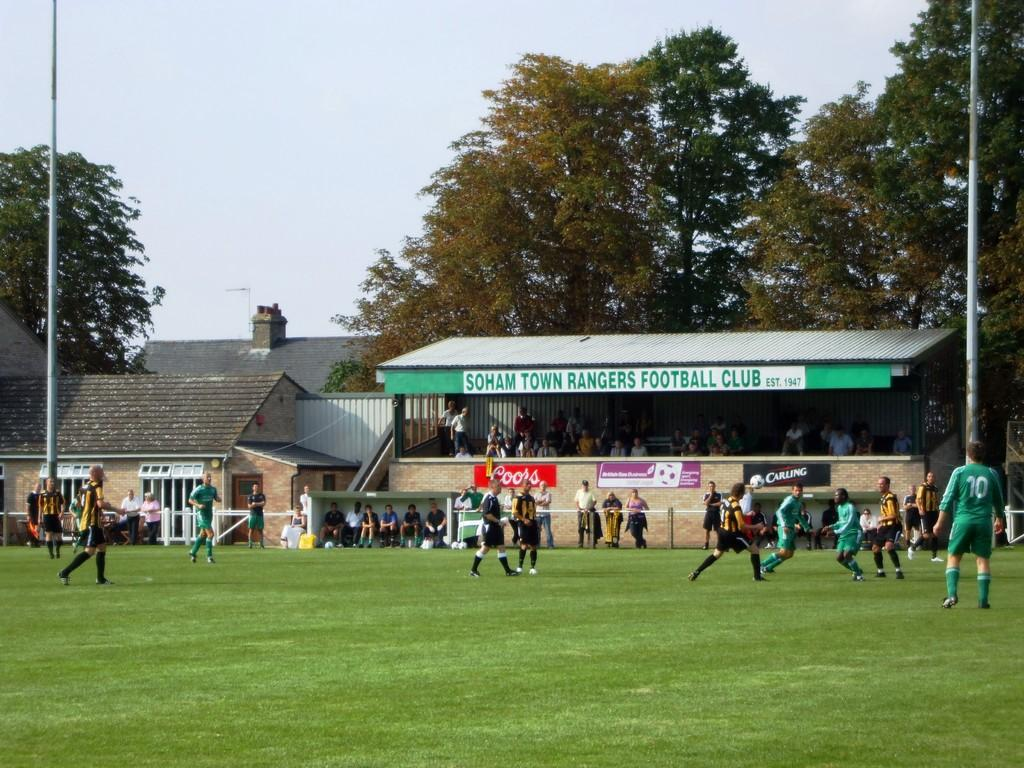<image>
Present a compact description of the photo's key features. a green awning with the name soham town rangers on it 